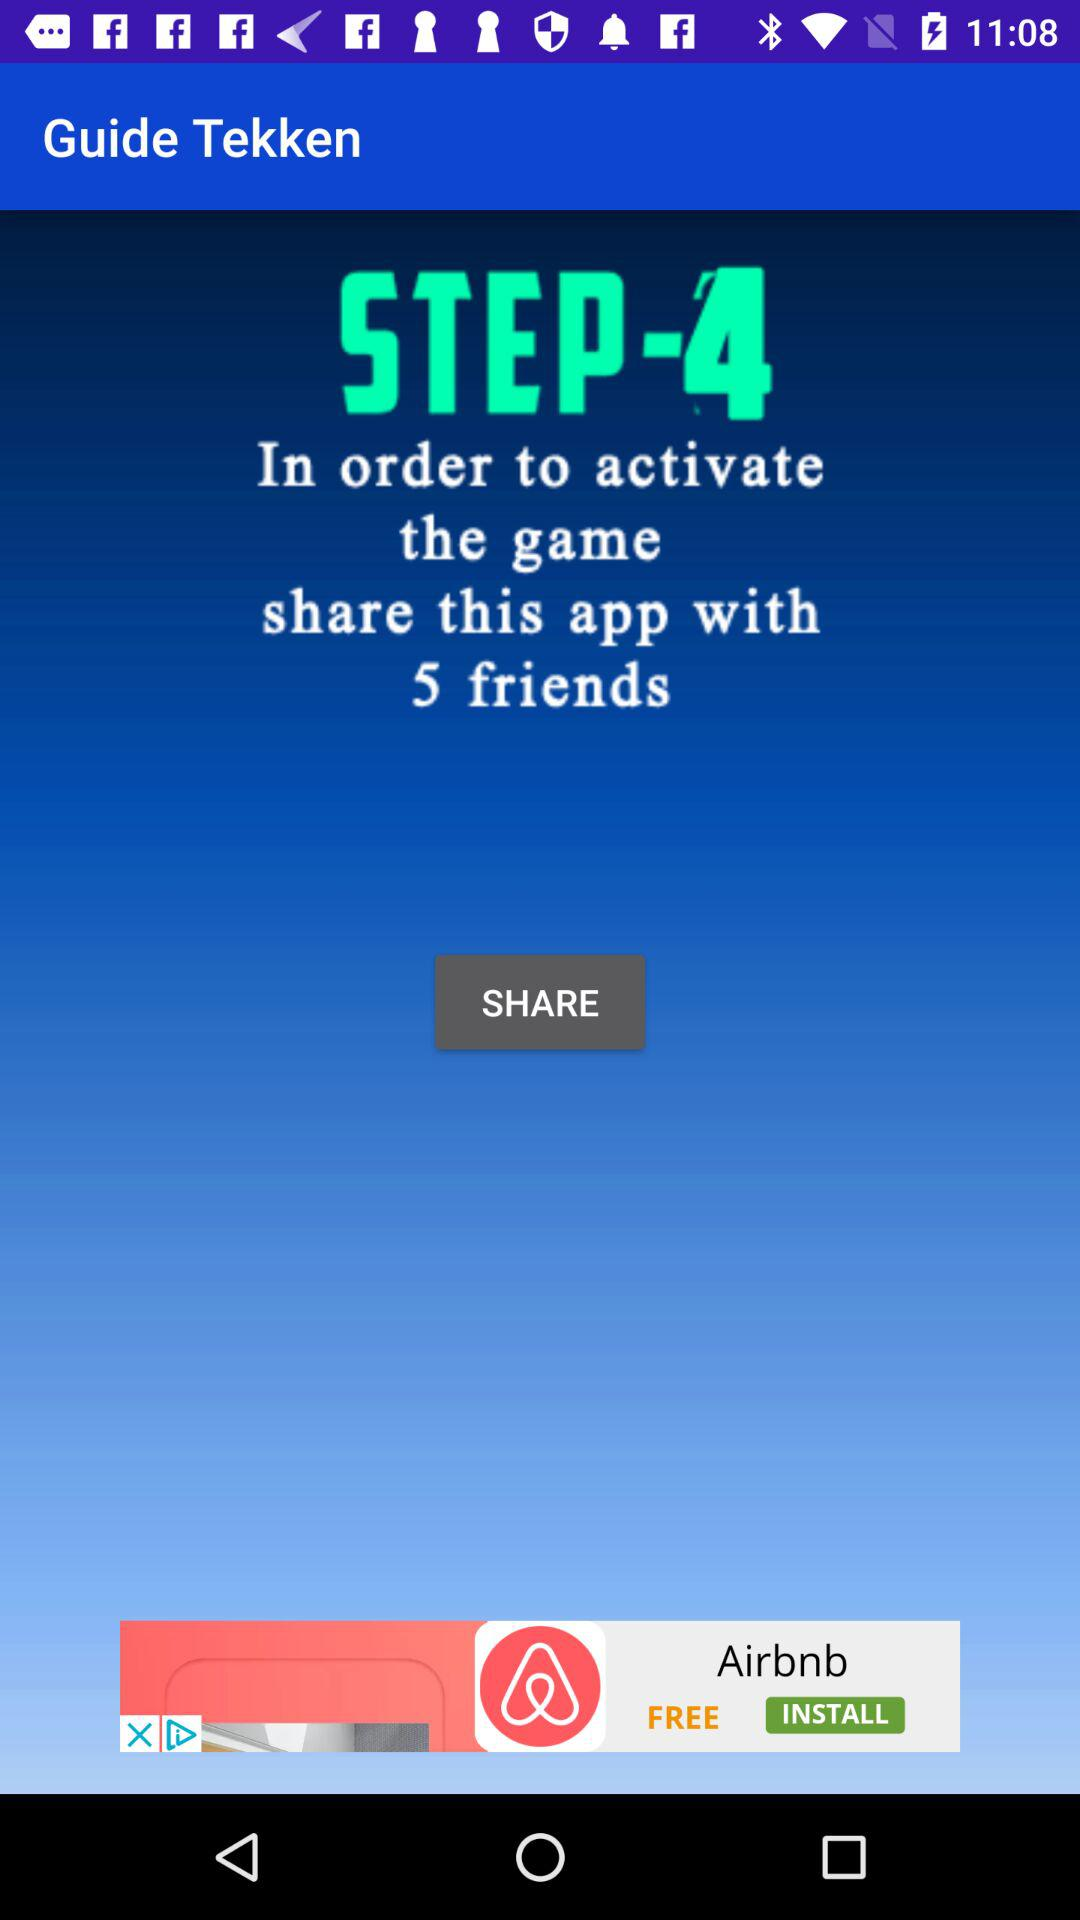How many friends do you need to share the app with in order to activate the game? In order to activate the game, you need to share the app with 5 friends. 